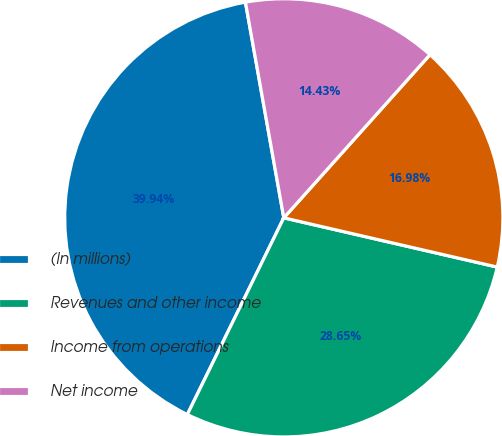<chart> <loc_0><loc_0><loc_500><loc_500><pie_chart><fcel>(In millions)<fcel>Revenues and other income<fcel>Income from operations<fcel>Net income<nl><fcel>39.94%<fcel>28.65%<fcel>16.98%<fcel>14.43%<nl></chart> 